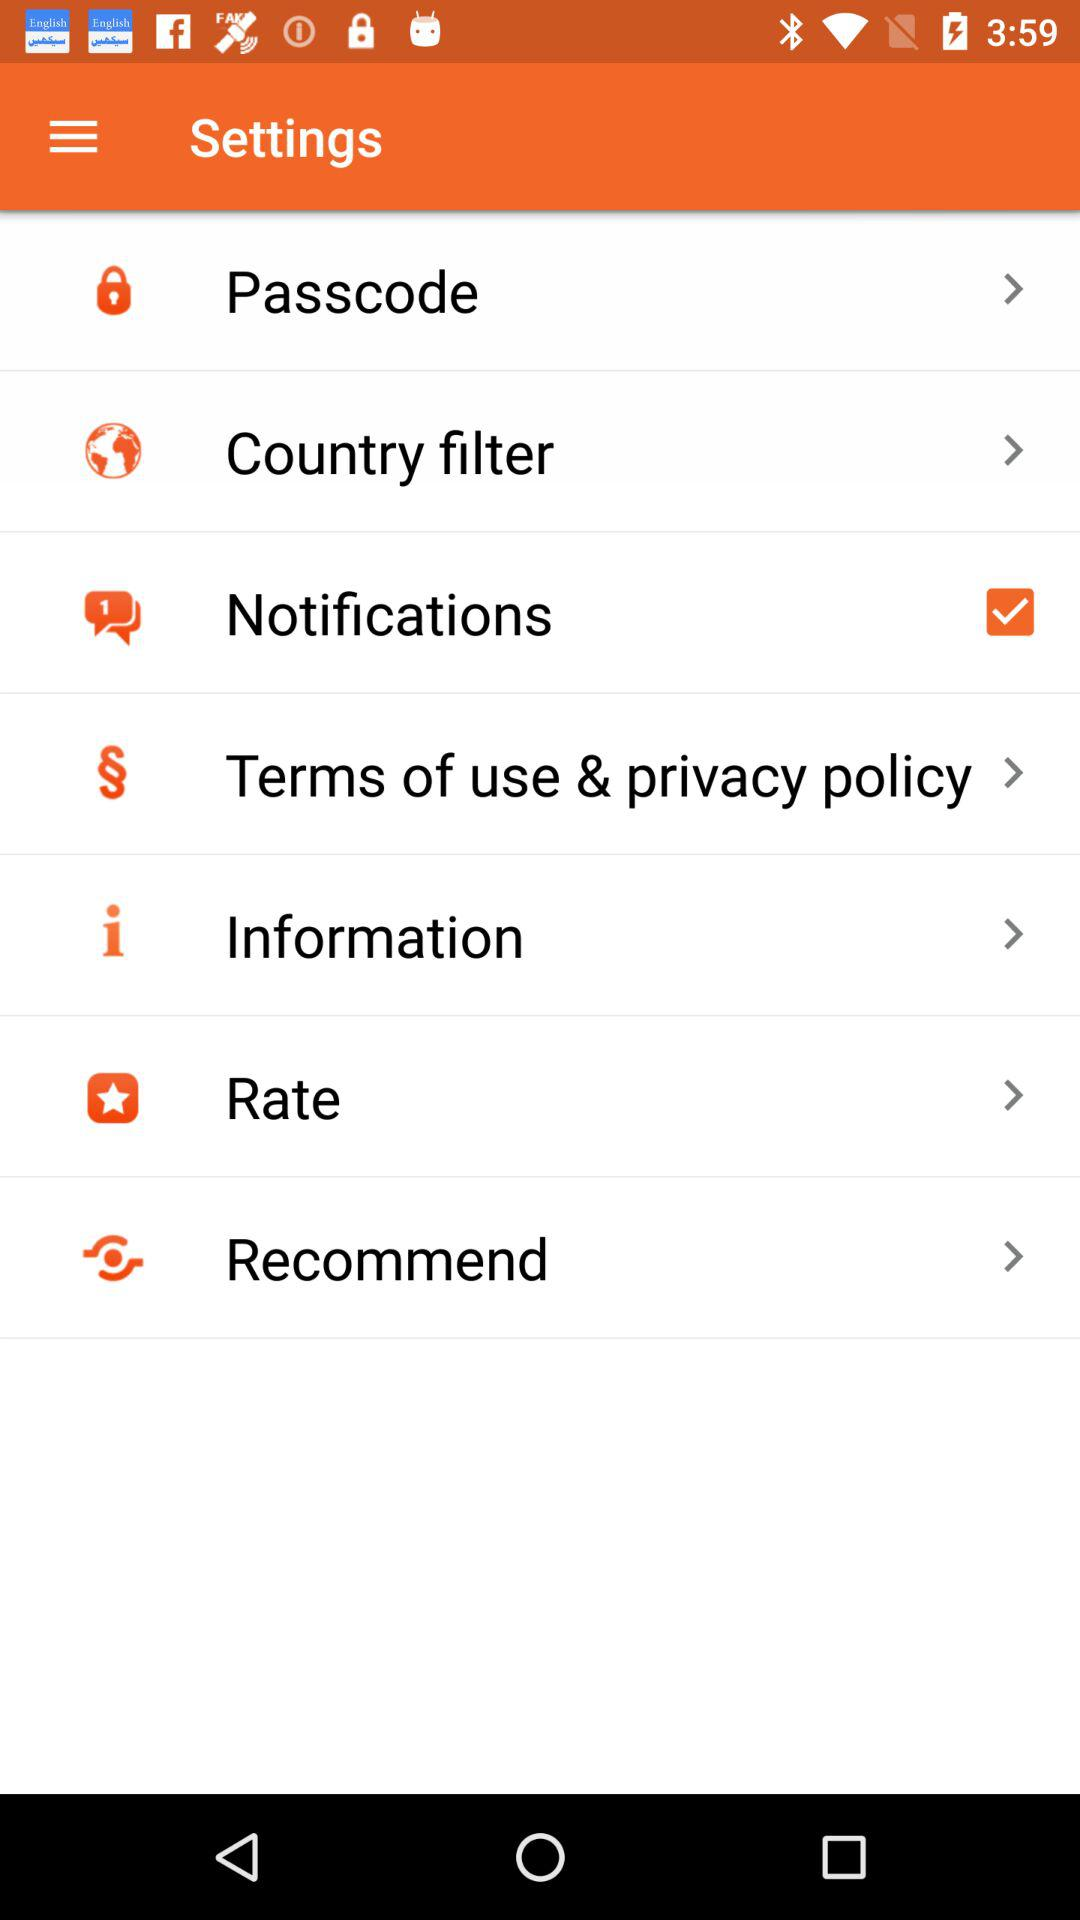What's the status of "Notifications"? The status is "on". 